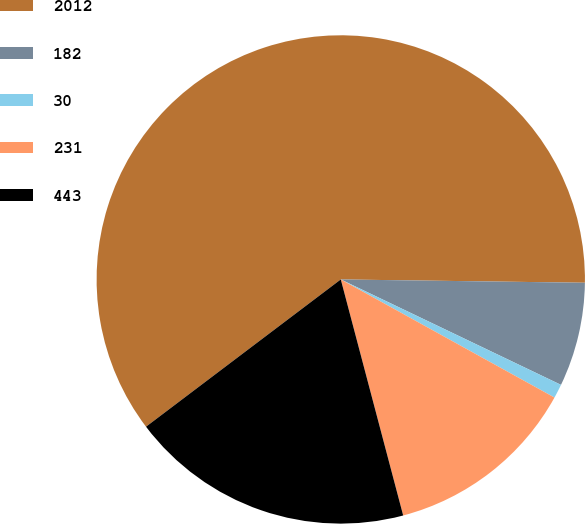Convert chart to OTSL. <chart><loc_0><loc_0><loc_500><loc_500><pie_chart><fcel>2012<fcel>182<fcel>30<fcel>231<fcel>443<nl><fcel>60.52%<fcel>6.89%<fcel>0.93%<fcel>12.85%<fcel>18.81%<nl></chart> 